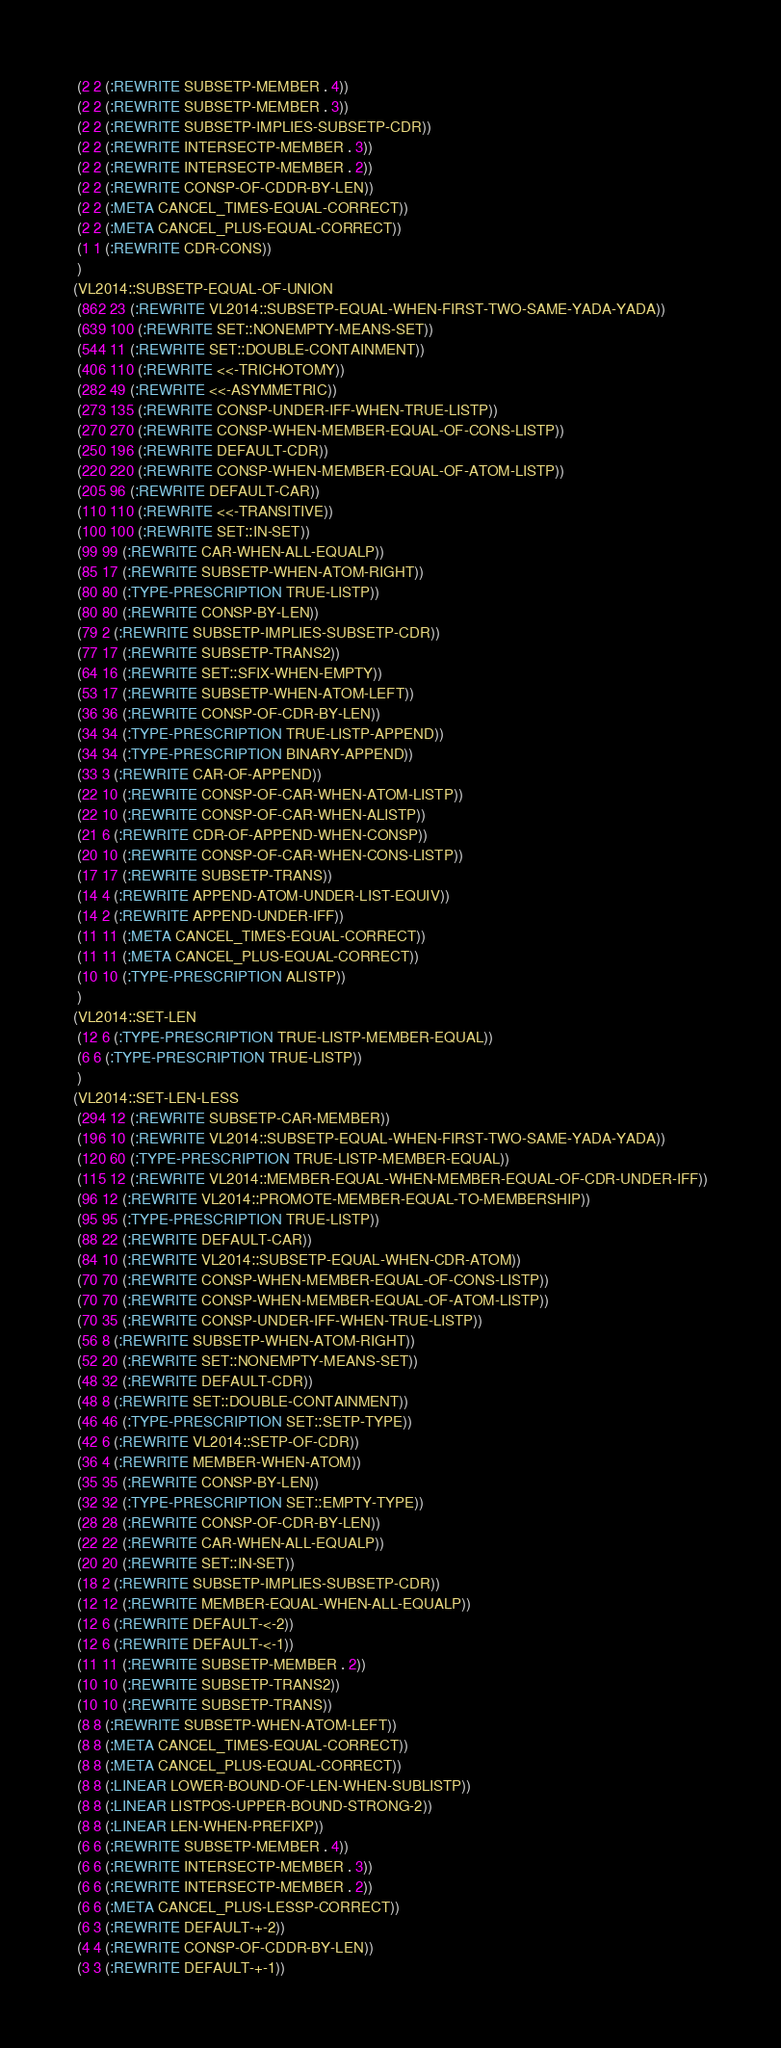<code> <loc_0><loc_0><loc_500><loc_500><_Lisp_> (2 2 (:REWRITE SUBSETP-MEMBER . 4))
 (2 2 (:REWRITE SUBSETP-MEMBER . 3))
 (2 2 (:REWRITE SUBSETP-IMPLIES-SUBSETP-CDR))
 (2 2 (:REWRITE INTERSECTP-MEMBER . 3))
 (2 2 (:REWRITE INTERSECTP-MEMBER . 2))
 (2 2 (:REWRITE CONSP-OF-CDDR-BY-LEN))
 (2 2 (:META CANCEL_TIMES-EQUAL-CORRECT))
 (2 2 (:META CANCEL_PLUS-EQUAL-CORRECT))
 (1 1 (:REWRITE CDR-CONS))
 )
(VL2014::SUBSETP-EQUAL-OF-UNION
 (862 23 (:REWRITE VL2014::SUBSETP-EQUAL-WHEN-FIRST-TWO-SAME-YADA-YADA))
 (639 100 (:REWRITE SET::NONEMPTY-MEANS-SET))
 (544 11 (:REWRITE SET::DOUBLE-CONTAINMENT))
 (406 110 (:REWRITE <<-TRICHOTOMY))
 (282 49 (:REWRITE <<-ASYMMETRIC))
 (273 135 (:REWRITE CONSP-UNDER-IFF-WHEN-TRUE-LISTP))
 (270 270 (:REWRITE CONSP-WHEN-MEMBER-EQUAL-OF-CONS-LISTP))
 (250 196 (:REWRITE DEFAULT-CDR))
 (220 220 (:REWRITE CONSP-WHEN-MEMBER-EQUAL-OF-ATOM-LISTP))
 (205 96 (:REWRITE DEFAULT-CAR))
 (110 110 (:REWRITE <<-TRANSITIVE))
 (100 100 (:REWRITE SET::IN-SET))
 (99 99 (:REWRITE CAR-WHEN-ALL-EQUALP))
 (85 17 (:REWRITE SUBSETP-WHEN-ATOM-RIGHT))
 (80 80 (:TYPE-PRESCRIPTION TRUE-LISTP))
 (80 80 (:REWRITE CONSP-BY-LEN))
 (79 2 (:REWRITE SUBSETP-IMPLIES-SUBSETP-CDR))
 (77 17 (:REWRITE SUBSETP-TRANS2))
 (64 16 (:REWRITE SET::SFIX-WHEN-EMPTY))
 (53 17 (:REWRITE SUBSETP-WHEN-ATOM-LEFT))
 (36 36 (:REWRITE CONSP-OF-CDR-BY-LEN))
 (34 34 (:TYPE-PRESCRIPTION TRUE-LISTP-APPEND))
 (34 34 (:TYPE-PRESCRIPTION BINARY-APPEND))
 (33 3 (:REWRITE CAR-OF-APPEND))
 (22 10 (:REWRITE CONSP-OF-CAR-WHEN-ATOM-LISTP))
 (22 10 (:REWRITE CONSP-OF-CAR-WHEN-ALISTP))
 (21 6 (:REWRITE CDR-OF-APPEND-WHEN-CONSP))
 (20 10 (:REWRITE CONSP-OF-CAR-WHEN-CONS-LISTP))
 (17 17 (:REWRITE SUBSETP-TRANS))
 (14 4 (:REWRITE APPEND-ATOM-UNDER-LIST-EQUIV))
 (14 2 (:REWRITE APPEND-UNDER-IFF))
 (11 11 (:META CANCEL_TIMES-EQUAL-CORRECT))
 (11 11 (:META CANCEL_PLUS-EQUAL-CORRECT))
 (10 10 (:TYPE-PRESCRIPTION ALISTP))
 )
(VL2014::SET-LEN
 (12 6 (:TYPE-PRESCRIPTION TRUE-LISTP-MEMBER-EQUAL))
 (6 6 (:TYPE-PRESCRIPTION TRUE-LISTP))
 )
(VL2014::SET-LEN-LESS
 (294 12 (:REWRITE SUBSETP-CAR-MEMBER))
 (196 10 (:REWRITE VL2014::SUBSETP-EQUAL-WHEN-FIRST-TWO-SAME-YADA-YADA))
 (120 60 (:TYPE-PRESCRIPTION TRUE-LISTP-MEMBER-EQUAL))
 (115 12 (:REWRITE VL2014::MEMBER-EQUAL-WHEN-MEMBER-EQUAL-OF-CDR-UNDER-IFF))
 (96 12 (:REWRITE VL2014::PROMOTE-MEMBER-EQUAL-TO-MEMBERSHIP))
 (95 95 (:TYPE-PRESCRIPTION TRUE-LISTP))
 (88 22 (:REWRITE DEFAULT-CAR))
 (84 10 (:REWRITE VL2014::SUBSETP-EQUAL-WHEN-CDR-ATOM))
 (70 70 (:REWRITE CONSP-WHEN-MEMBER-EQUAL-OF-CONS-LISTP))
 (70 70 (:REWRITE CONSP-WHEN-MEMBER-EQUAL-OF-ATOM-LISTP))
 (70 35 (:REWRITE CONSP-UNDER-IFF-WHEN-TRUE-LISTP))
 (56 8 (:REWRITE SUBSETP-WHEN-ATOM-RIGHT))
 (52 20 (:REWRITE SET::NONEMPTY-MEANS-SET))
 (48 32 (:REWRITE DEFAULT-CDR))
 (48 8 (:REWRITE SET::DOUBLE-CONTAINMENT))
 (46 46 (:TYPE-PRESCRIPTION SET::SETP-TYPE))
 (42 6 (:REWRITE VL2014::SETP-OF-CDR))
 (36 4 (:REWRITE MEMBER-WHEN-ATOM))
 (35 35 (:REWRITE CONSP-BY-LEN))
 (32 32 (:TYPE-PRESCRIPTION SET::EMPTY-TYPE))
 (28 28 (:REWRITE CONSP-OF-CDR-BY-LEN))
 (22 22 (:REWRITE CAR-WHEN-ALL-EQUALP))
 (20 20 (:REWRITE SET::IN-SET))
 (18 2 (:REWRITE SUBSETP-IMPLIES-SUBSETP-CDR))
 (12 12 (:REWRITE MEMBER-EQUAL-WHEN-ALL-EQUALP))
 (12 6 (:REWRITE DEFAULT-<-2))
 (12 6 (:REWRITE DEFAULT-<-1))
 (11 11 (:REWRITE SUBSETP-MEMBER . 2))
 (10 10 (:REWRITE SUBSETP-TRANS2))
 (10 10 (:REWRITE SUBSETP-TRANS))
 (8 8 (:REWRITE SUBSETP-WHEN-ATOM-LEFT))
 (8 8 (:META CANCEL_TIMES-EQUAL-CORRECT))
 (8 8 (:META CANCEL_PLUS-EQUAL-CORRECT))
 (8 8 (:LINEAR LOWER-BOUND-OF-LEN-WHEN-SUBLISTP))
 (8 8 (:LINEAR LISTPOS-UPPER-BOUND-STRONG-2))
 (8 8 (:LINEAR LEN-WHEN-PREFIXP))
 (6 6 (:REWRITE SUBSETP-MEMBER . 4))
 (6 6 (:REWRITE INTERSECTP-MEMBER . 3))
 (6 6 (:REWRITE INTERSECTP-MEMBER . 2))
 (6 6 (:META CANCEL_PLUS-LESSP-CORRECT))
 (6 3 (:REWRITE DEFAULT-+-2))
 (4 4 (:REWRITE CONSP-OF-CDDR-BY-LEN))
 (3 3 (:REWRITE DEFAULT-+-1))</code> 